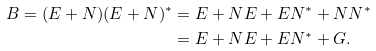Convert formula to latex. <formula><loc_0><loc_0><loc_500><loc_500>B = ( E + N ) ( E + N ) ^ { * } & = E + N E + E N ^ { * } + N N ^ { * } \\ & = E + N E + E N ^ { * } + G .</formula> 